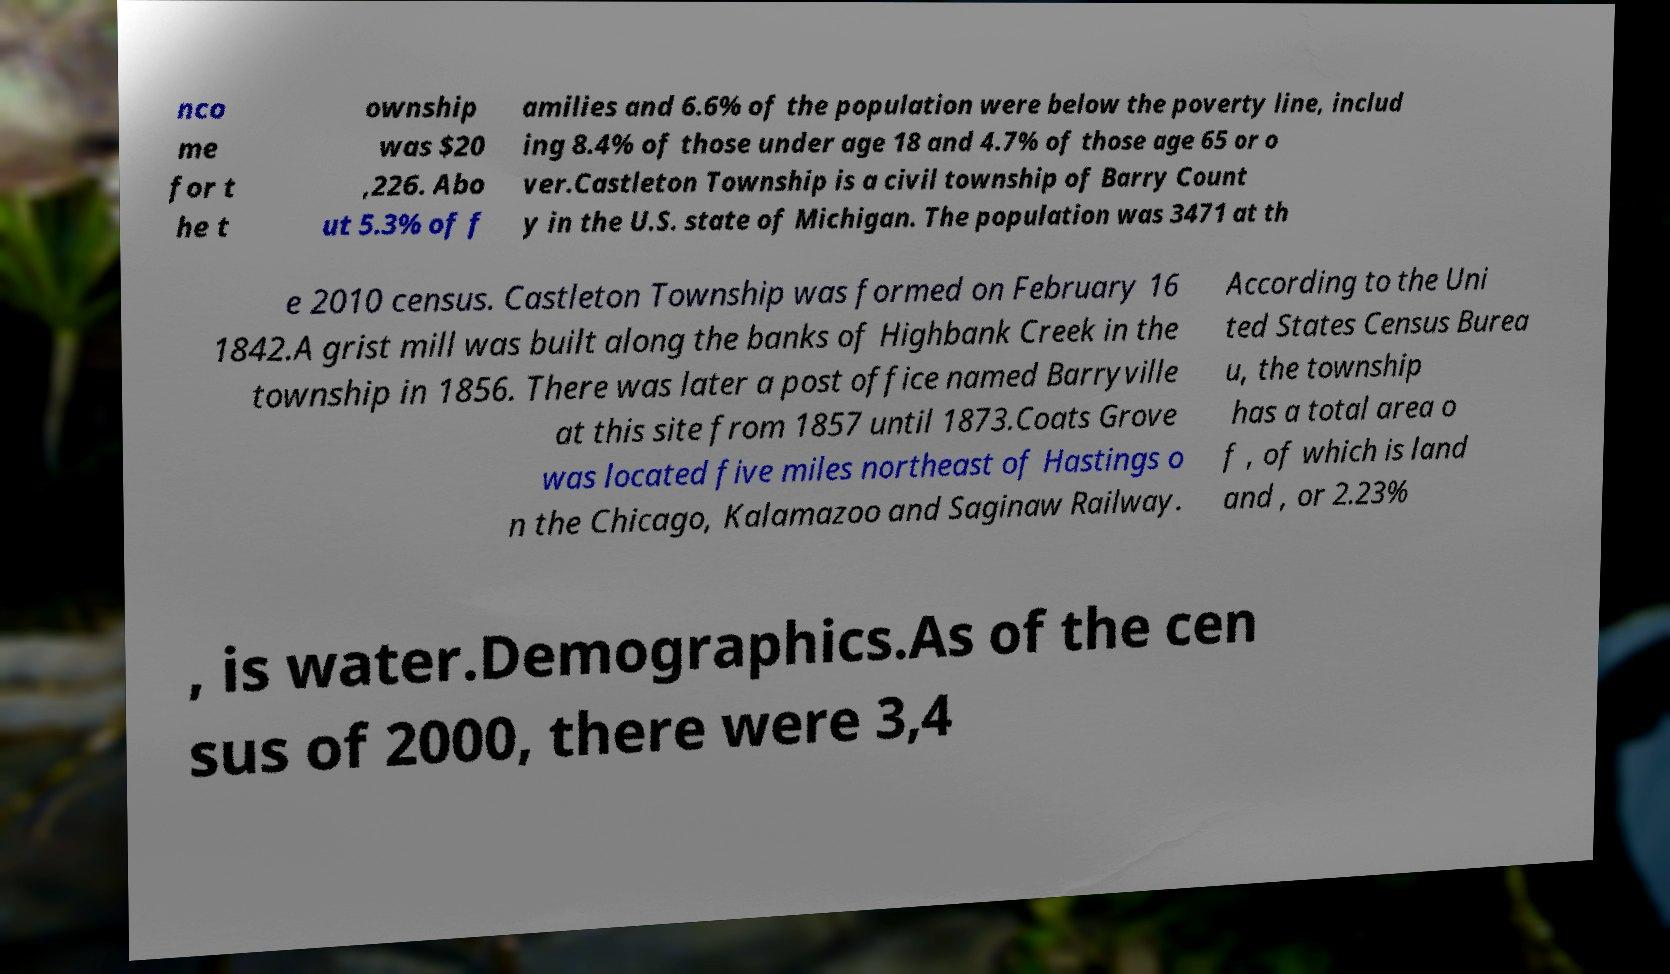Could you assist in decoding the text presented in this image and type it out clearly? nco me for t he t ownship was $20 ,226. Abo ut 5.3% of f amilies and 6.6% of the population were below the poverty line, includ ing 8.4% of those under age 18 and 4.7% of those age 65 or o ver.Castleton Township is a civil township of Barry Count y in the U.S. state of Michigan. The population was 3471 at th e 2010 census. Castleton Township was formed on February 16 1842.A grist mill was built along the banks of Highbank Creek in the township in 1856. There was later a post office named Barryville at this site from 1857 until 1873.Coats Grove was located five miles northeast of Hastings o n the Chicago, Kalamazoo and Saginaw Railway. According to the Uni ted States Census Burea u, the township has a total area o f , of which is land and , or 2.23% , is water.Demographics.As of the cen sus of 2000, there were 3,4 